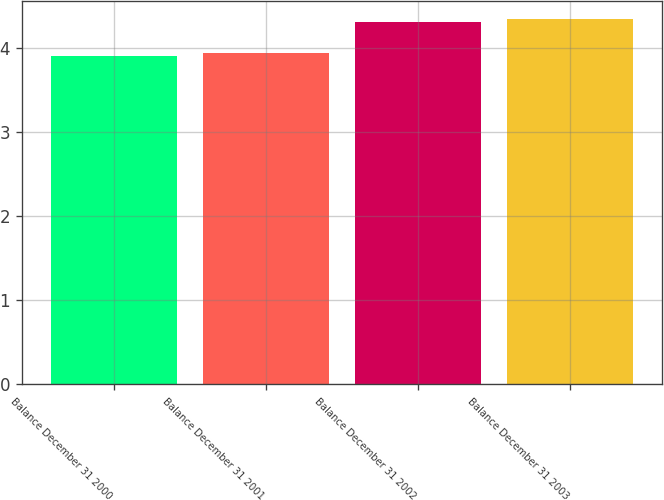Convert chart to OTSL. <chart><loc_0><loc_0><loc_500><loc_500><bar_chart><fcel>Balance December 31 2000<fcel>Balance December 31 2001<fcel>Balance December 31 2002<fcel>Balance December 31 2003<nl><fcel>3.9<fcel>3.94<fcel>4.3<fcel>4.34<nl></chart> 